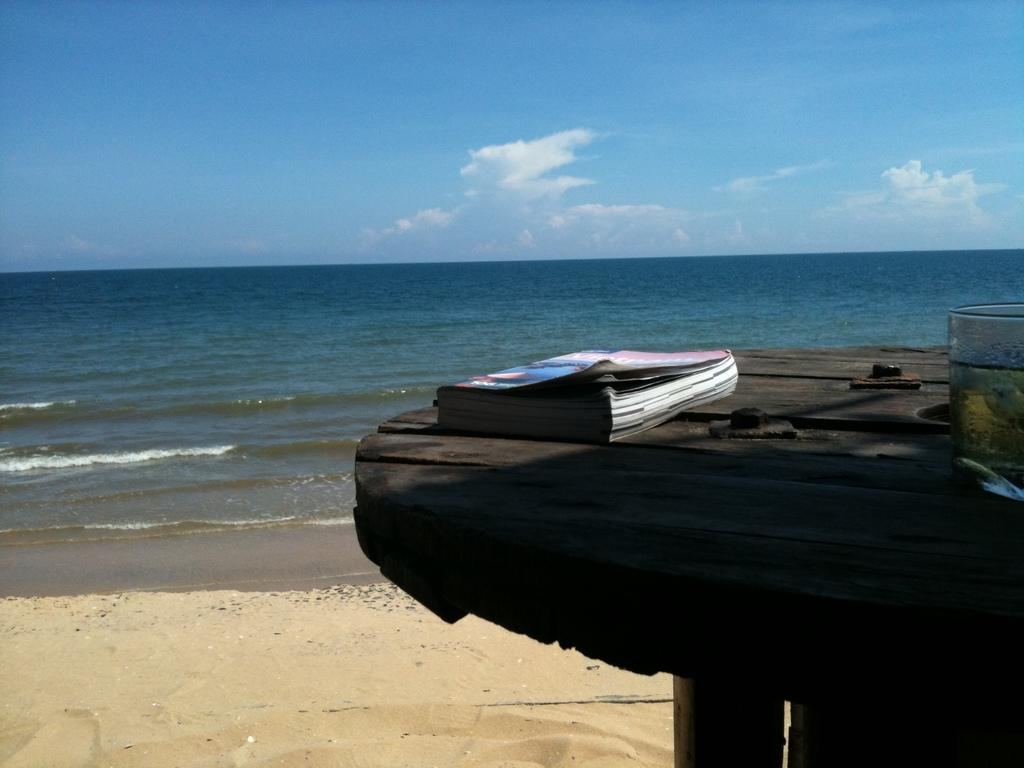What object is on the table in the image? There is a book on the table. What else can be seen on the table? There is a glass with liquid and a slice on the table. Where is the table located in the image? The table is in the foreground. What can be seen in the background of the image? There is sand, water, and clouds in the sky visible in the background. What type of street can be seen in the image? There is no street visible in the image; it features a table with a book, a glass with liquid and a slice, and a background with sand, water, and clouds in the sky. 